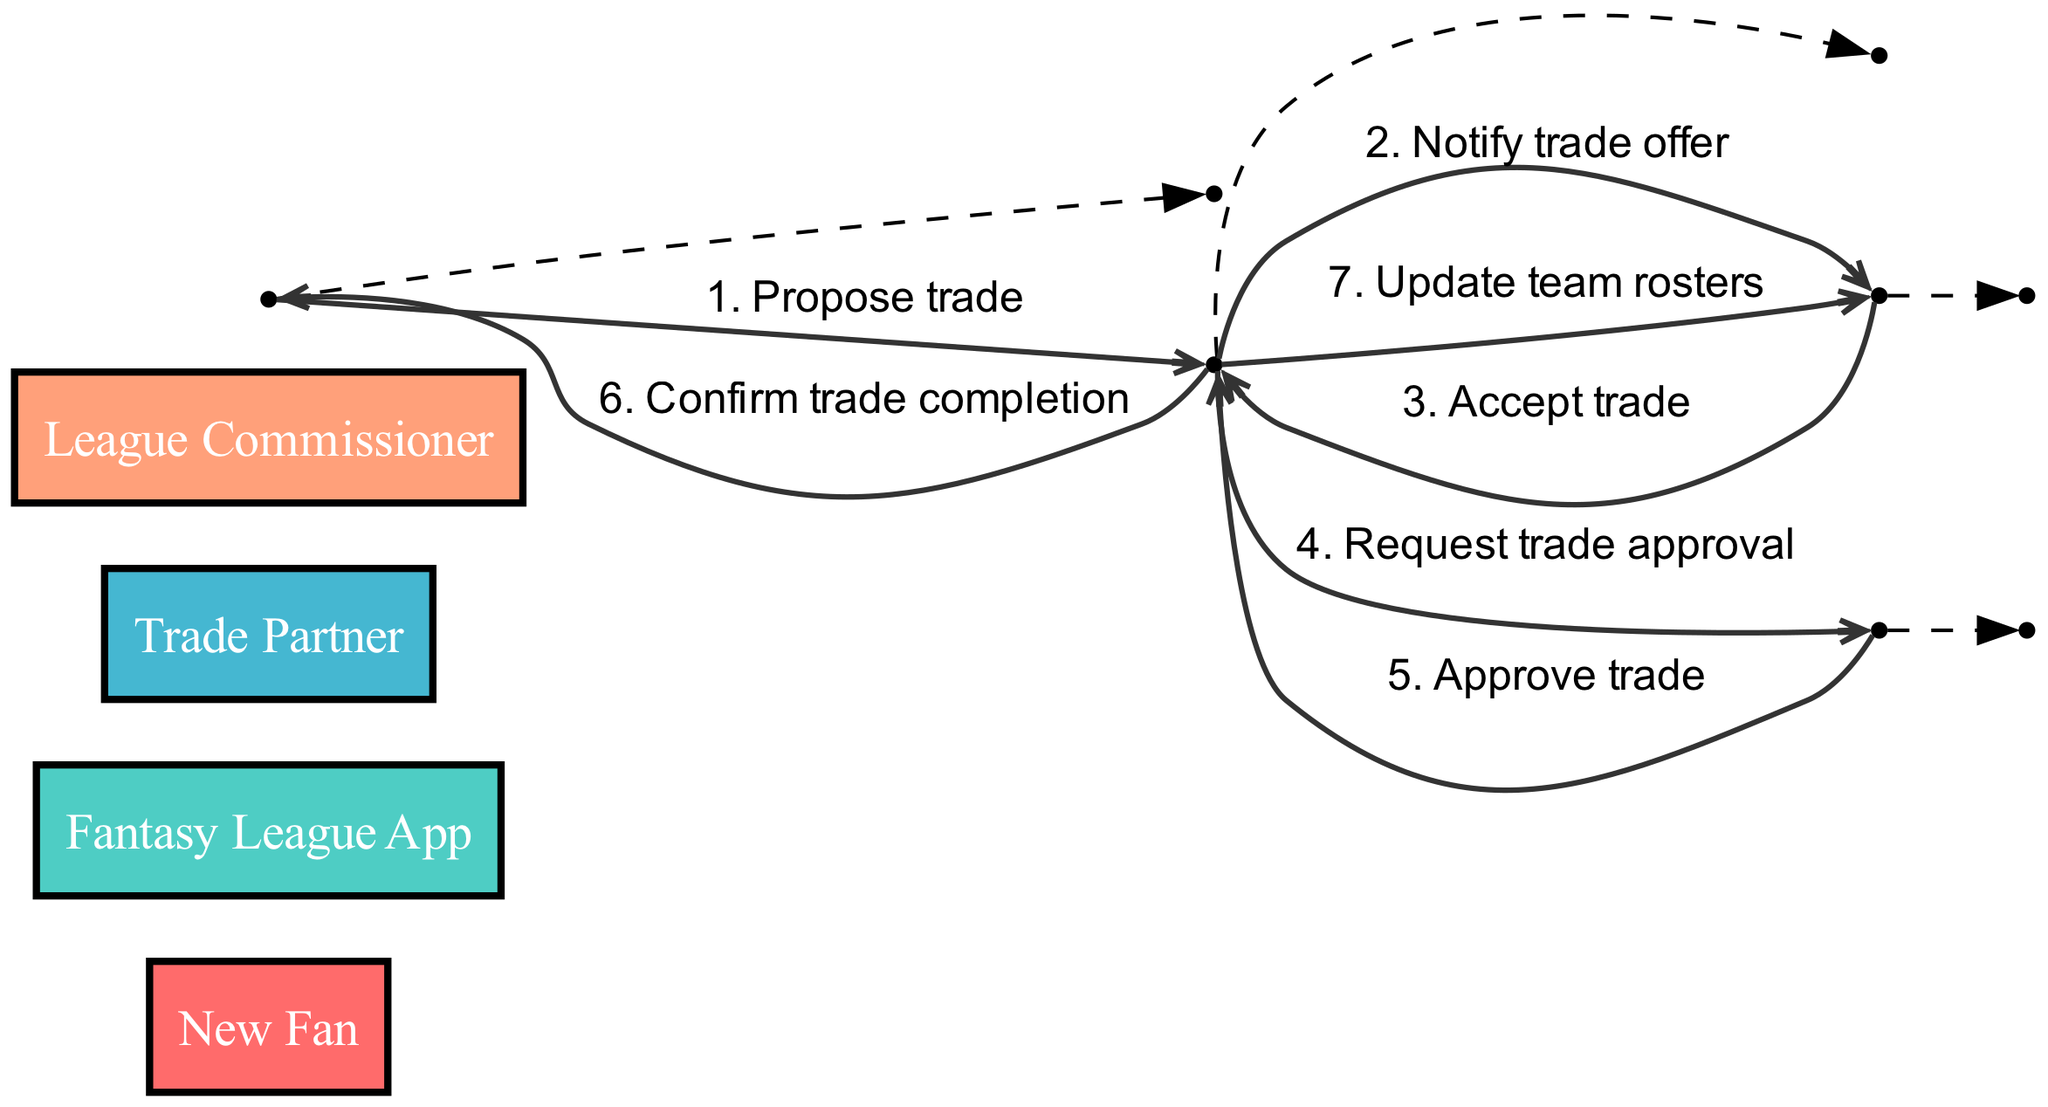What is the first action in the trade procedure? The first action is initiated by the "New Fan" who proposes a trade to the "Fantasy League App".
Answer: Propose trade How many actors are involved in the diagram? The diagram includes four distinct actors: "New Fan", "Fantasy League App", "Trade Partner", and "League Commissioner".
Answer: Four What message does the "Fantasy League App" send to the "Trade Partner"? The message sent by the "Fantasy League App" to the "Trade Partner" is a notification about the trade offer.
Answer: Notify trade offer Which actor is responsible for approving the trade? The "League Commissioner" is tasked with approving the trade as per the sequence of actions shown in the diagram.
Answer: League Commissioner What happens after the "Trade Partner" accepts the trade? After the "Trade Partner" accepts the trade, the "Fantasy League App" requests trade approval from the "League Commissioner".
Answer: Request trade approval How many messages are exchanged in total during the trade procedure? There are a total of six messages exchanged throughout the entire trade procedure from start to finish.
Answer: Six What is the final message received by the "New Fan"? The final message received by the "New Fan" is a confirmation of the trade completion from the "Fantasy League App".
Answer: Confirm trade completion What occurs immediately after the "League Commissioner" approves the trade? Immediately after the trade is approved by the "League Commissioner", the "Fantasy League App" updates the team rosters.
Answer: Update team rosters 